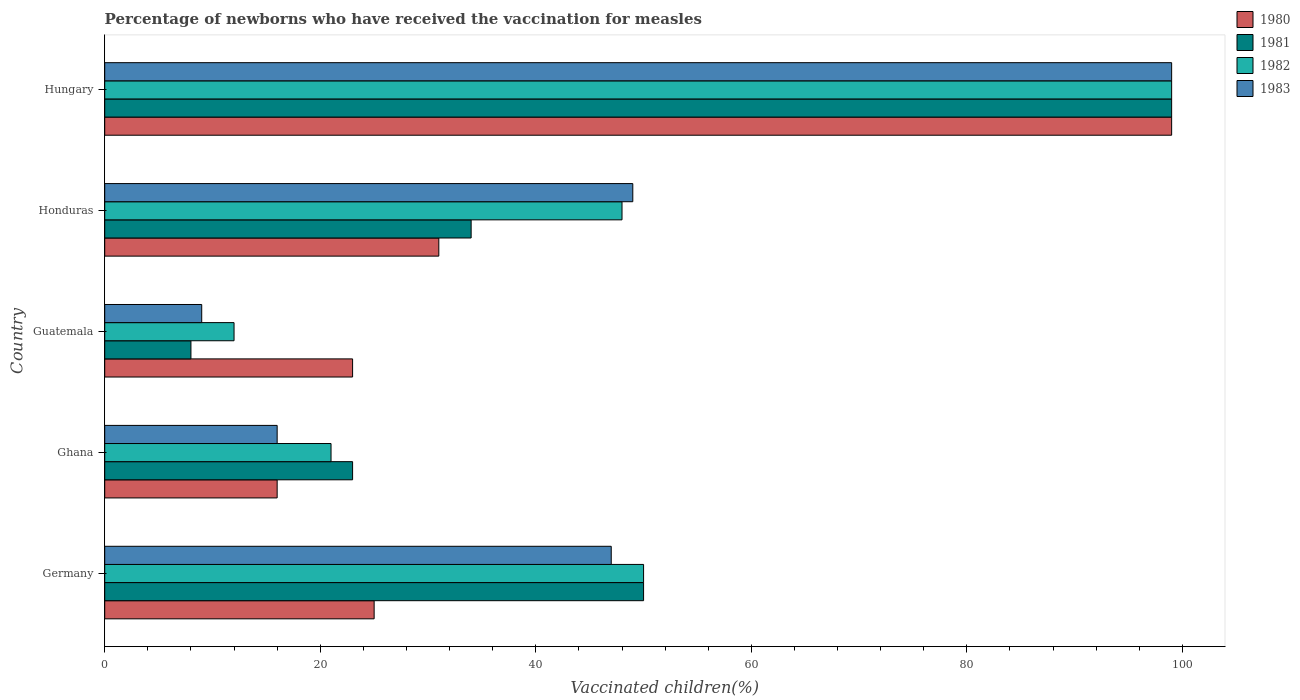What is the label of the 2nd group of bars from the top?
Your answer should be very brief. Honduras. In how many cases, is the number of bars for a given country not equal to the number of legend labels?
Offer a very short reply. 0. What is the percentage of vaccinated children in 1981 in Honduras?
Offer a terse response. 34. In which country was the percentage of vaccinated children in 1981 maximum?
Your answer should be very brief. Hungary. In which country was the percentage of vaccinated children in 1983 minimum?
Offer a terse response. Guatemala. What is the total percentage of vaccinated children in 1980 in the graph?
Your answer should be compact. 194. What is the difference between the percentage of vaccinated children in 1981 in Honduras and that in Hungary?
Offer a very short reply. -65. What is the difference between the percentage of vaccinated children in 1980 in Guatemala and the percentage of vaccinated children in 1982 in Hungary?
Your answer should be very brief. -76. What is the average percentage of vaccinated children in 1980 per country?
Your response must be concise. 38.8. What is the ratio of the percentage of vaccinated children in 1980 in Guatemala to that in Hungary?
Provide a succinct answer. 0.23. Is the difference between the percentage of vaccinated children in 1983 in Ghana and Guatemala greater than the difference between the percentage of vaccinated children in 1981 in Ghana and Guatemala?
Your response must be concise. No. What is the difference between the highest and the lowest percentage of vaccinated children in 1980?
Your response must be concise. 83. In how many countries, is the percentage of vaccinated children in 1981 greater than the average percentage of vaccinated children in 1981 taken over all countries?
Your response must be concise. 2. What does the 2nd bar from the top in Hungary represents?
Give a very brief answer. 1982. What does the 4th bar from the bottom in Hungary represents?
Ensure brevity in your answer.  1983. How many countries are there in the graph?
Offer a terse response. 5. What is the difference between two consecutive major ticks on the X-axis?
Your answer should be compact. 20. Are the values on the major ticks of X-axis written in scientific E-notation?
Your response must be concise. No. How are the legend labels stacked?
Your answer should be very brief. Vertical. What is the title of the graph?
Provide a succinct answer. Percentage of newborns who have received the vaccination for measles. What is the label or title of the X-axis?
Your answer should be compact. Vaccinated children(%). What is the label or title of the Y-axis?
Your answer should be compact. Country. What is the Vaccinated children(%) of 1980 in Germany?
Your response must be concise. 25. What is the Vaccinated children(%) of 1981 in Germany?
Your response must be concise. 50. What is the Vaccinated children(%) in 1982 in Germany?
Provide a short and direct response. 50. What is the Vaccinated children(%) in 1983 in Germany?
Give a very brief answer. 47. What is the Vaccinated children(%) in 1980 in Ghana?
Offer a very short reply. 16. What is the Vaccinated children(%) of 1981 in Ghana?
Make the answer very short. 23. What is the Vaccinated children(%) in 1982 in Guatemala?
Provide a short and direct response. 12. What is the Vaccinated children(%) of 1980 in Honduras?
Your answer should be very brief. 31. What is the Vaccinated children(%) in 1982 in Honduras?
Give a very brief answer. 48. What is the Vaccinated children(%) in 1983 in Honduras?
Make the answer very short. 49. What is the Vaccinated children(%) in 1980 in Hungary?
Give a very brief answer. 99. What is the Vaccinated children(%) in 1982 in Hungary?
Provide a short and direct response. 99. What is the Vaccinated children(%) of 1983 in Hungary?
Your response must be concise. 99. Across all countries, what is the maximum Vaccinated children(%) in 1982?
Your answer should be compact. 99. Across all countries, what is the minimum Vaccinated children(%) of 1982?
Your answer should be compact. 12. Across all countries, what is the minimum Vaccinated children(%) in 1983?
Provide a succinct answer. 9. What is the total Vaccinated children(%) in 1980 in the graph?
Your answer should be very brief. 194. What is the total Vaccinated children(%) in 1981 in the graph?
Keep it short and to the point. 214. What is the total Vaccinated children(%) of 1982 in the graph?
Ensure brevity in your answer.  230. What is the total Vaccinated children(%) of 1983 in the graph?
Your answer should be compact. 220. What is the difference between the Vaccinated children(%) of 1980 in Germany and that in Ghana?
Ensure brevity in your answer.  9. What is the difference between the Vaccinated children(%) in 1980 in Germany and that in Guatemala?
Keep it short and to the point. 2. What is the difference between the Vaccinated children(%) in 1981 in Germany and that in Guatemala?
Make the answer very short. 42. What is the difference between the Vaccinated children(%) in 1982 in Germany and that in Guatemala?
Provide a short and direct response. 38. What is the difference between the Vaccinated children(%) of 1983 in Germany and that in Guatemala?
Provide a succinct answer. 38. What is the difference between the Vaccinated children(%) of 1981 in Germany and that in Honduras?
Give a very brief answer. 16. What is the difference between the Vaccinated children(%) in 1980 in Germany and that in Hungary?
Your response must be concise. -74. What is the difference between the Vaccinated children(%) of 1981 in Germany and that in Hungary?
Make the answer very short. -49. What is the difference between the Vaccinated children(%) in 1982 in Germany and that in Hungary?
Give a very brief answer. -49. What is the difference between the Vaccinated children(%) of 1983 in Germany and that in Hungary?
Keep it short and to the point. -52. What is the difference between the Vaccinated children(%) of 1981 in Ghana and that in Guatemala?
Provide a short and direct response. 15. What is the difference between the Vaccinated children(%) in 1982 in Ghana and that in Guatemala?
Ensure brevity in your answer.  9. What is the difference between the Vaccinated children(%) in 1981 in Ghana and that in Honduras?
Your answer should be compact. -11. What is the difference between the Vaccinated children(%) in 1982 in Ghana and that in Honduras?
Offer a very short reply. -27. What is the difference between the Vaccinated children(%) in 1983 in Ghana and that in Honduras?
Your response must be concise. -33. What is the difference between the Vaccinated children(%) in 1980 in Ghana and that in Hungary?
Your answer should be very brief. -83. What is the difference between the Vaccinated children(%) of 1981 in Ghana and that in Hungary?
Provide a succinct answer. -76. What is the difference between the Vaccinated children(%) of 1982 in Ghana and that in Hungary?
Your answer should be compact. -78. What is the difference between the Vaccinated children(%) in 1983 in Ghana and that in Hungary?
Offer a very short reply. -83. What is the difference between the Vaccinated children(%) in 1980 in Guatemala and that in Honduras?
Make the answer very short. -8. What is the difference between the Vaccinated children(%) in 1982 in Guatemala and that in Honduras?
Make the answer very short. -36. What is the difference between the Vaccinated children(%) in 1980 in Guatemala and that in Hungary?
Offer a terse response. -76. What is the difference between the Vaccinated children(%) of 1981 in Guatemala and that in Hungary?
Your response must be concise. -91. What is the difference between the Vaccinated children(%) of 1982 in Guatemala and that in Hungary?
Keep it short and to the point. -87. What is the difference between the Vaccinated children(%) of 1983 in Guatemala and that in Hungary?
Provide a succinct answer. -90. What is the difference between the Vaccinated children(%) of 1980 in Honduras and that in Hungary?
Your answer should be compact. -68. What is the difference between the Vaccinated children(%) in 1981 in Honduras and that in Hungary?
Offer a terse response. -65. What is the difference between the Vaccinated children(%) of 1982 in Honduras and that in Hungary?
Provide a succinct answer. -51. What is the difference between the Vaccinated children(%) in 1980 in Germany and the Vaccinated children(%) in 1982 in Ghana?
Give a very brief answer. 4. What is the difference between the Vaccinated children(%) of 1981 in Germany and the Vaccinated children(%) of 1983 in Ghana?
Ensure brevity in your answer.  34. What is the difference between the Vaccinated children(%) in 1982 in Germany and the Vaccinated children(%) in 1983 in Ghana?
Ensure brevity in your answer.  34. What is the difference between the Vaccinated children(%) of 1980 in Germany and the Vaccinated children(%) of 1981 in Guatemala?
Your answer should be very brief. 17. What is the difference between the Vaccinated children(%) in 1980 in Germany and the Vaccinated children(%) in 1982 in Guatemala?
Your answer should be very brief. 13. What is the difference between the Vaccinated children(%) in 1981 in Germany and the Vaccinated children(%) in 1982 in Guatemala?
Keep it short and to the point. 38. What is the difference between the Vaccinated children(%) in 1981 in Germany and the Vaccinated children(%) in 1983 in Guatemala?
Give a very brief answer. 41. What is the difference between the Vaccinated children(%) of 1980 in Germany and the Vaccinated children(%) of 1982 in Honduras?
Give a very brief answer. -23. What is the difference between the Vaccinated children(%) of 1980 in Germany and the Vaccinated children(%) of 1983 in Honduras?
Keep it short and to the point. -24. What is the difference between the Vaccinated children(%) in 1982 in Germany and the Vaccinated children(%) in 1983 in Honduras?
Offer a terse response. 1. What is the difference between the Vaccinated children(%) of 1980 in Germany and the Vaccinated children(%) of 1981 in Hungary?
Your answer should be very brief. -74. What is the difference between the Vaccinated children(%) in 1980 in Germany and the Vaccinated children(%) in 1982 in Hungary?
Make the answer very short. -74. What is the difference between the Vaccinated children(%) of 1980 in Germany and the Vaccinated children(%) of 1983 in Hungary?
Your response must be concise. -74. What is the difference between the Vaccinated children(%) of 1981 in Germany and the Vaccinated children(%) of 1982 in Hungary?
Ensure brevity in your answer.  -49. What is the difference between the Vaccinated children(%) in 1981 in Germany and the Vaccinated children(%) in 1983 in Hungary?
Your answer should be very brief. -49. What is the difference between the Vaccinated children(%) of 1982 in Germany and the Vaccinated children(%) of 1983 in Hungary?
Provide a succinct answer. -49. What is the difference between the Vaccinated children(%) of 1980 in Ghana and the Vaccinated children(%) of 1981 in Guatemala?
Give a very brief answer. 8. What is the difference between the Vaccinated children(%) in 1982 in Ghana and the Vaccinated children(%) in 1983 in Guatemala?
Your response must be concise. 12. What is the difference between the Vaccinated children(%) in 1980 in Ghana and the Vaccinated children(%) in 1981 in Honduras?
Your response must be concise. -18. What is the difference between the Vaccinated children(%) of 1980 in Ghana and the Vaccinated children(%) of 1982 in Honduras?
Provide a succinct answer. -32. What is the difference between the Vaccinated children(%) of 1980 in Ghana and the Vaccinated children(%) of 1983 in Honduras?
Your answer should be compact. -33. What is the difference between the Vaccinated children(%) of 1981 in Ghana and the Vaccinated children(%) of 1983 in Honduras?
Your response must be concise. -26. What is the difference between the Vaccinated children(%) of 1982 in Ghana and the Vaccinated children(%) of 1983 in Honduras?
Your response must be concise. -28. What is the difference between the Vaccinated children(%) in 1980 in Ghana and the Vaccinated children(%) in 1981 in Hungary?
Offer a very short reply. -83. What is the difference between the Vaccinated children(%) in 1980 in Ghana and the Vaccinated children(%) in 1982 in Hungary?
Your response must be concise. -83. What is the difference between the Vaccinated children(%) of 1980 in Ghana and the Vaccinated children(%) of 1983 in Hungary?
Your response must be concise. -83. What is the difference between the Vaccinated children(%) of 1981 in Ghana and the Vaccinated children(%) of 1982 in Hungary?
Make the answer very short. -76. What is the difference between the Vaccinated children(%) in 1981 in Ghana and the Vaccinated children(%) in 1983 in Hungary?
Keep it short and to the point. -76. What is the difference between the Vaccinated children(%) of 1982 in Ghana and the Vaccinated children(%) of 1983 in Hungary?
Offer a very short reply. -78. What is the difference between the Vaccinated children(%) of 1980 in Guatemala and the Vaccinated children(%) of 1981 in Honduras?
Your answer should be compact. -11. What is the difference between the Vaccinated children(%) of 1980 in Guatemala and the Vaccinated children(%) of 1982 in Honduras?
Your response must be concise. -25. What is the difference between the Vaccinated children(%) of 1980 in Guatemala and the Vaccinated children(%) of 1983 in Honduras?
Ensure brevity in your answer.  -26. What is the difference between the Vaccinated children(%) in 1981 in Guatemala and the Vaccinated children(%) in 1983 in Honduras?
Ensure brevity in your answer.  -41. What is the difference between the Vaccinated children(%) of 1982 in Guatemala and the Vaccinated children(%) of 1983 in Honduras?
Your answer should be compact. -37. What is the difference between the Vaccinated children(%) of 1980 in Guatemala and the Vaccinated children(%) of 1981 in Hungary?
Provide a succinct answer. -76. What is the difference between the Vaccinated children(%) of 1980 in Guatemala and the Vaccinated children(%) of 1982 in Hungary?
Keep it short and to the point. -76. What is the difference between the Vaccinated children(%) of 1980 in Guatemala and the Vaccinated children(%) of 1983 in Hungary?
Provide a short and direct response. -76. What is the difference between the Vaccinated children(%) of 1981 in Guatemala and the Vaccinated children(%) of 1982 in Hungary?
Ensure brevity in your answer.  -91. What is the difference between the Vaccinated children(%) of 1981 in Guatemala and the Vaccinated children(%) of 1983 in Hungary?
Provide a succinct answer. -91. What is the difference between the Vaccinated children(%) in 1982 in Guatemala and the Vaccinated children(%) in 1983 in Hungary?
Give a very brief answer. -87. What is the difference between the Vaccinated children(%) of 1980 in Honduras and the Vaccinated children(%) of 1981 in Hungary?
Make the answer very short. -68. What is the difference between the Vaccinated children(%) of 1980 in Honduras and the Vaccinated children(%) of 1982 in Hungary?
Your response must be concise. -68. What is the difference between the Vaccinated children(%) of 1980 in Honduras and the Vaccinated children(%) of 1983 in Hungary?
Your answer should be compact. -68. What is the difference between the Vaccinated children(%) in 1981 in Honduras and the Vaccinated children(%) in 1982 in Hungary?
Your response must be concise. -65. What is the difference between the Vaccinated children(%) in 1981 in Honduras and the Vaccinated children(%) in 1983 in Hungary?
Offer a terse response. -65. What is the difference between the Vaccinated children(%) in 1982 in Honduras and the Vaccinated children(%) in 1983 in Hungary?
Your response must be concise. -51. What is the average Vaccinated children(%) of 1980 per country?
Provide a short and direct response. 38.8. What is the average Vaccinated children(%) in 1981 per country?
Make the answer very short. 42.8. What is the average Vaccinated children(%) of 1982 per country?
Offer a terse response. 46. What is the average Vaccinated children(%) of 1983 per country?
Provide a short and direct response. 44. What is the difference between the Vaccinated children(%) of 1980 and Vaccinated children(%) of 1982 in Germany?
Your response must be concise. -25. What is the difference between the Vaccinated children(%) in 1981 and Vaccinated children(%) in 1983 in Germany?
Keep it short and to the point. 3. What is the difference between the Vaccinated children(%) of 1982 and Vaccinated children(%) of 1983 in Germany?
Give a very brief answer. 3. What is the difference between the Vaccinated children(%) of 1980 and Vaccinated children(%) of 1981 in Ghana?
Make the answer very short. -7. What is the difference between the Vaccinated children(%) in 1980 and Vaccinated children(%) in 1982 in Ghana?
Keep it short and to the point. -5. What is the difference between the Vaccinated children(%) in 1980 and Vaccinated children(%) in 1983 in Ghana?
Make the answer very short. 0. What is the difference between the Vaccinated children(%) of 1981 and Vaccinated children(%) of 1982 in Guatemala?
Your answer should be very brief. -4. What is the difference between the Vaccinated children(%) in 1981 and Vaccinated children(%) in 1983 in Guatemala?
Offer a terse response. -1. What is the difference between the Vaccinated children(%) in 1982 and Vaccinated children(%) in 1983 in Honduras?
Provide a short and direct response. -1. What is the difference between the Vaccinated children(%) in 1980 and Vaccinated children(%) in 1983 in Hungary?
Keep it short and to the point. 0. What is the difference between the Vaccinated children(%) of 1982 and Vaccinated children(%) of 1983 in Hungary?
Give a very brief answer. 0. What is the ratio of the Vaccinated children(%) of 1980 in Germany to that in Ghana?
Provide a succinct answer. 1.56. What is the ratio of the Vaccinated children(%) of 1981 in Germany to that in Ghana?
Give a very brief answer. 2.17. What is the ratio of the Vaccinated children(%) in 1982 in Germany to that in Ghana?
Provide a succinct answer. 2.38. What is the ratio of the Vaccinated children(%) of 1983 in Germany to that in Ghana?
Your response must be concise. 2.94. What is the ratio of the Vaccinated children(%) of 1980 in Germany to that in Guatemala?
Offer a terse response. 1.09. What is the ratio of the Vaccinated children(%) in 1981 in Germany to that in Guatemala?
Keep it short and to the point. 6.25. What is the ratio of the Vaccinated children(%) of 1982 in Germany to that in Guatemala?
Your answer should be compact. 4.17. What is the ratio of the Vaccinated children(%) in 1983 in Germany to that in Guatemala?
Give a very brief answer. 5.22. What is the ratio of the Vaccinated children(%) of 1980 in Germany to that in Honduras?
Ensure brevity in your answer.  0.81. What is the ratio of the Vaccinated children(%) in 1981 in Germany to that in Honduras?
Keep it short and to the point. 1.47. What is the ratio of the Vaccinated children(%) of 1982 in Germany to that in Honduras?
Keep it short and to the point. 1.04. What is the ratio of the Vaccinated children(%) of 1983 in Germany to that in Honduras?
Ensure brevity in your answer.  0.96. What is the ratio of the Vaccinated children(%) in 1980 in Germany to that in Hungary?
Your response must be concise. 0.25. What is the ratio of the Vaccinated children(%) of 1981 in Germany to that in Hungary?
Make the answer very short. 0.51. What is the ratio of the Vaccinated children(%) in 1982 in Germany to that in Hungary?
Offer a very short reply. 0.51. What is the ratio of the Vaccinated children(%) of 1983 in Germany to that in Hungary?
Make the answer very short. 0.47. What is the ratio of the Vaccinated children(%) in 1980 in Ghana to that in Guatemala?
Make the answer very short. 0.7. What is the ratio of the Vaccinated children(%) of 1981 in Ghana to that in Guatemala?
Offer a very short reply. 2.88. What is the ratio of the Vaccinated children(%) in 1983 in Ghana to that in Guatemala?
Your answer should be very brief. 1.78. What is the ratio of the Vaccinated children(%) of 1980 in Ghana to that in Honduras?
Provide a succinct answer. 0.52. What is the ratio of the Vaccinated children(%) of 1981 in Ghana to that in Honduras?
Keep it short and to the point. 0.68. What is the ratio of the Vaccinated children(%) in 1982 in Ghana to that in Honduras?
Make the answer very short. 0.44. What is the ratio of the Vaccinated children(%) of 1983 in Ghana to that in Honduras?
Provide a succinct answer. 0.33. What is the ratio of the Vaccinated children(%) of 1980 in Ghana to that in Hungary?
Ensure brevity in your answer.  0.16. What is the ratio of the Vaccinated children(%) of 1981 in Ghana to that in Hungary?
Keep it short and to the point. 0.23. What is the ratio of the Vaccinated children(%) in 1982 in Ghana to that in Hungary?
Ensure brevity in your answer.  0.21. What is the ratio of the Vaccinated children(%) of 1983 in Ghana to that in Hungary?
Provide a succinct answer. 0.16. What is the ratio of the Vaccinated children(%) in 1980 in Guatemala to that in Honduras?
Make the answer very short. 0.74. What is the ratio of the Vaccinated children(%) of 1981 in Guatemala to that in Honduras?
Offer a very short reply. 0.24. What is the ratio of the Vaccinated children(%) of 1983 in Guatemala to that in Honduras?
Ensure brevity in your answer.  0.18. What is the ratio of the Vaccinated children(%) of 1980 in Guatemala to that in Hungary?
Ensure brevity in your answer.  0.23. What is the ratio of the Vaccinated children(%) of 1981 in Guatemala to that in Hungary?
Your answer should be compact. 0.08. What is the ratio of the Vaccinated children(%) in 1982 in Guatemala to that in Hungary?
Your answer should be compact. 0.12. What is the ratio of the Vaccinated children(%) in 1983 in Guatemala to that in Hungary?
Offer a very short reply. 0.09. What is the ratio of the Vaccinated children(%) in 1980 in Honduras to that in Hungary?
Offer a terse response. 0.31. What is the ratio of the Vaccinated children(%) in 1981 in Honduras to that in Hungary?
Offer a terse response. 0.34. What is the ratio of the Vaccinated children(%) of 1982 in Honduras to that in Hungary?
Your answer should be compact. 0.48. What is the ratio of the Vaccinated children(%) in 1983 in Honduras to that in Hungary?
Give a very brief answer. 0.49. What is the difference between the highest and the second highest Vaccinated children(%) of 1980?
Provide a short and direct response. 68. What is the difference between the highest and the lowest Vaccinated children(%) of 1981?
Your response must be concise. 91. What is the difference between the highest and the lowest Vaccinated children(%) in 1982?
Provide a short and direct response. 87. What is the difference between the highest and the lowest Vaccinated children(%) in 1983?
Your answer should be very brief. 90. 